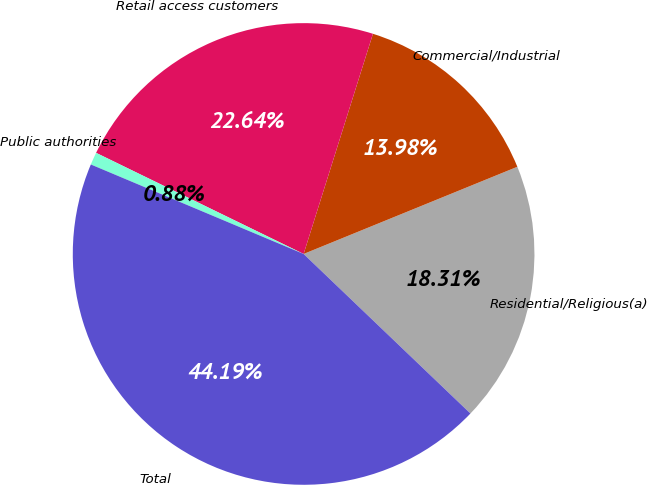<chart> <loc_0><loc_0><loc_500><loc_500><pie_chart><fcel>Residential/Religious(a)<fcel>Commercial/Industrial<fcel>Retail access customers<fcel>Public authorities<fcel>Total<nl><fcel>18.31%<fcel>13.98%<fcel>22.64%<fcel>0.88%<fcel>44.19%<nl></chart> 